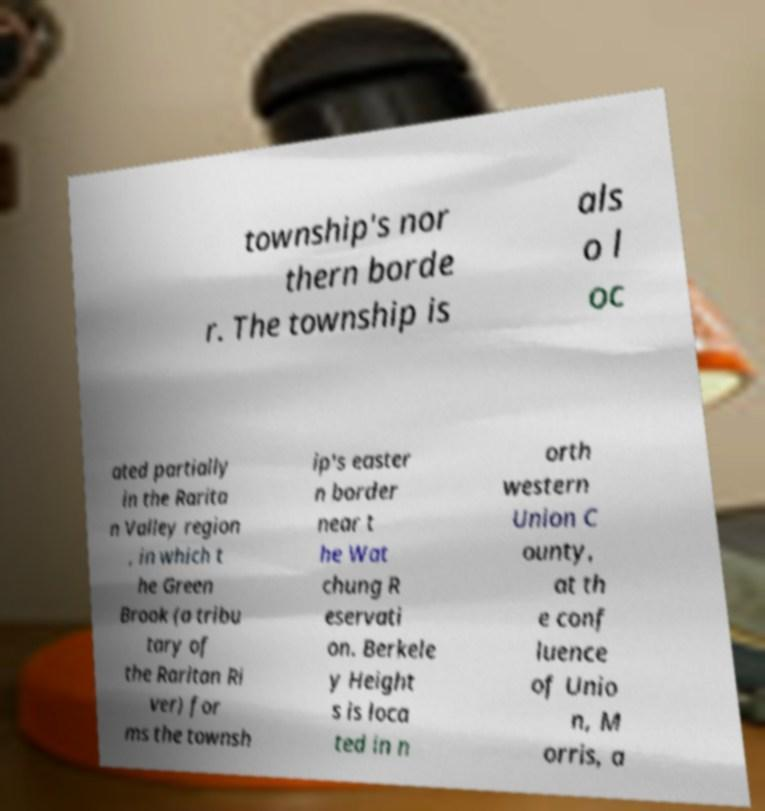Can you accurately transcribe the text from the provided image for me? township's nor thern borde r. The township is als o l oc ated partially in the Rarita n Valley region , in which t he Green Brook (a tribu tary of the Raritan Ri ver) for ms the townsh ip's easter n border near t he Wat chung R eservati on. Berkele y Height s is loca ted in n orth western Union C ounty, at th e conf luence of Unio n, M orris, a 